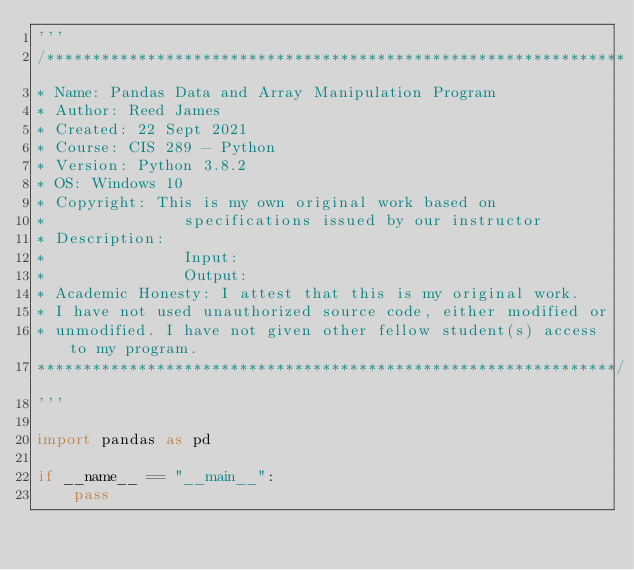Convert code to text. <code><loc_0><loc_0><loc_500><loc_500><_Python_>'''
/***************************************************************
* Name: Pandas Data and Array Manipulation Program
* Author: Reed James
* Created: 22 Sept 2021
* Course: CIS 289 - Python
* Version: Python 3.8.2
* OS: Windows 10
* Copyright: This is my own original work based on
*               specifications issued by our instructor
* Description: 
*               Input: 
*               Output: 
* Academic Honesty: I attest that this is my original work.
* I have not used unauthorized source code, either modified or
* unmodified. I have not given other fellow student(s) access to my program.
***************************************************************/
'''

import pandas as pd

if __name__ == "__main__":
    pass
</code> 